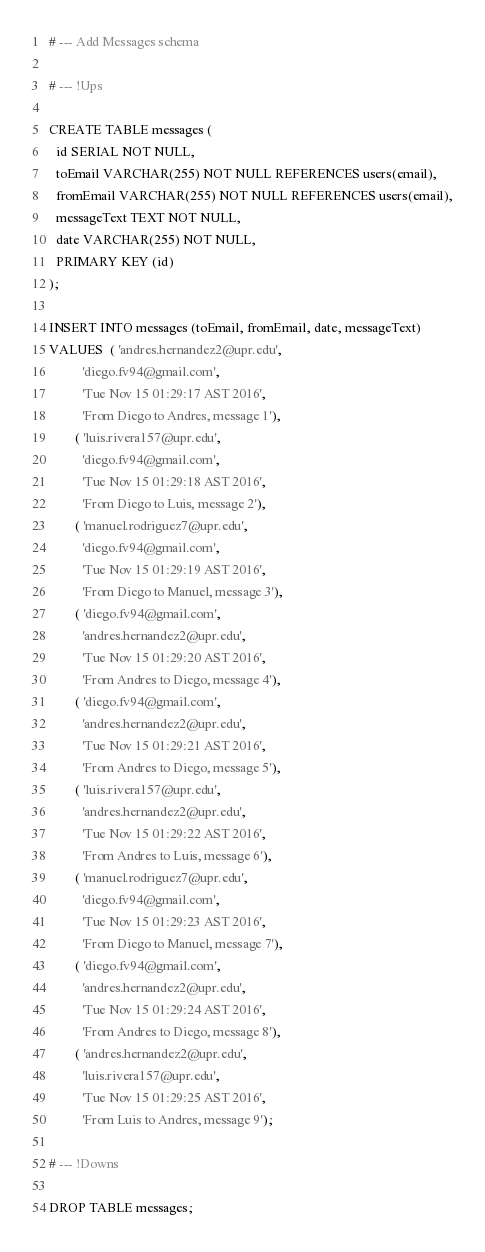<code> <loc_0><loc_0><loc_500><loc_500><_SQL_># --- Add Messages schema

# --- !Ups

CREATE TABLE messages (
  id SERIAL NOT NULL,
  toEmail VARCHAR(255) NOT NULL REFERENCES users(email),
  fromEmail VARCHAR(255) NOT NULL REFERENCES users(email),
  messageText TEXT NOT NULL,
  date VARCHAR(255) NOT NULL,
  PRIMARY KEY (id)
);

INSERT INTO messages (toEmail, fromEmail, date, messageText)
VALUES  ( 'andres.hernandez2@upr.edu',
          'diego.fv94@gmail.com',
          'Tue Nov 15 01:29:17 AST 2016',
          'From Diego to Andres, message 1'),
        ( 'luis.rivera157@upr.edu',
          'diego.fv94@gmail.com',
          'Tue Nov 15 01:29:18 AST 2016',
          'From Diego to Luis, message 2'),
        ( 'manuel.rodriguez7@upr.edu',
          'diego.fv94@gmail.com',
          'Tue Nov 15 01:29:19 AST 2016',
          'From Diego to Manuel, message 3'),
        ( 'diego.fv94@gmail.com',
          'andres.hernandez2@upr.edu',
          'Tue Nov 15 01:29:20 AST 2016',
          'From Andres to Diego, message 4'),
        ( 'diego.fv94@gmail.com',
          'andres.hernandez2@upr.edu',
          'Tue Nov 15 01:29:21 AST 2016',
          'From Andres to Diego, message 5'),
        ( 'luis.rivera157@upr.edu',
          'andres.hernandez2@upr.edu',
          'Tue Nov 15 01:29:22 AST 2016',
          'From Andres to Luis, message 6'),
        ( 'manuel.rodriguez7@upr.edu',
          'diego.fv94@gmail.com',
          'Tue Nov 15 01:29:23 AST 2016',
          'From Diego to Manuel, message 7'),
        ( 'diego.fv94@gmail.com',
          'andres.hernandez2@upr.edu',
          'Tue Nov 15 01:29:24 AST 2016',
          'From Andres to Diego, message 8'),
        ( 'andres.hernandez2@upr.edu',
          'luis.rivera157@upr.edu',
          'Tue Nov 15 01:29:25 AST 2016',
          'From Luis to Andres, message 9');

# --- !Downs

DROP TABLE messages;
</code> 